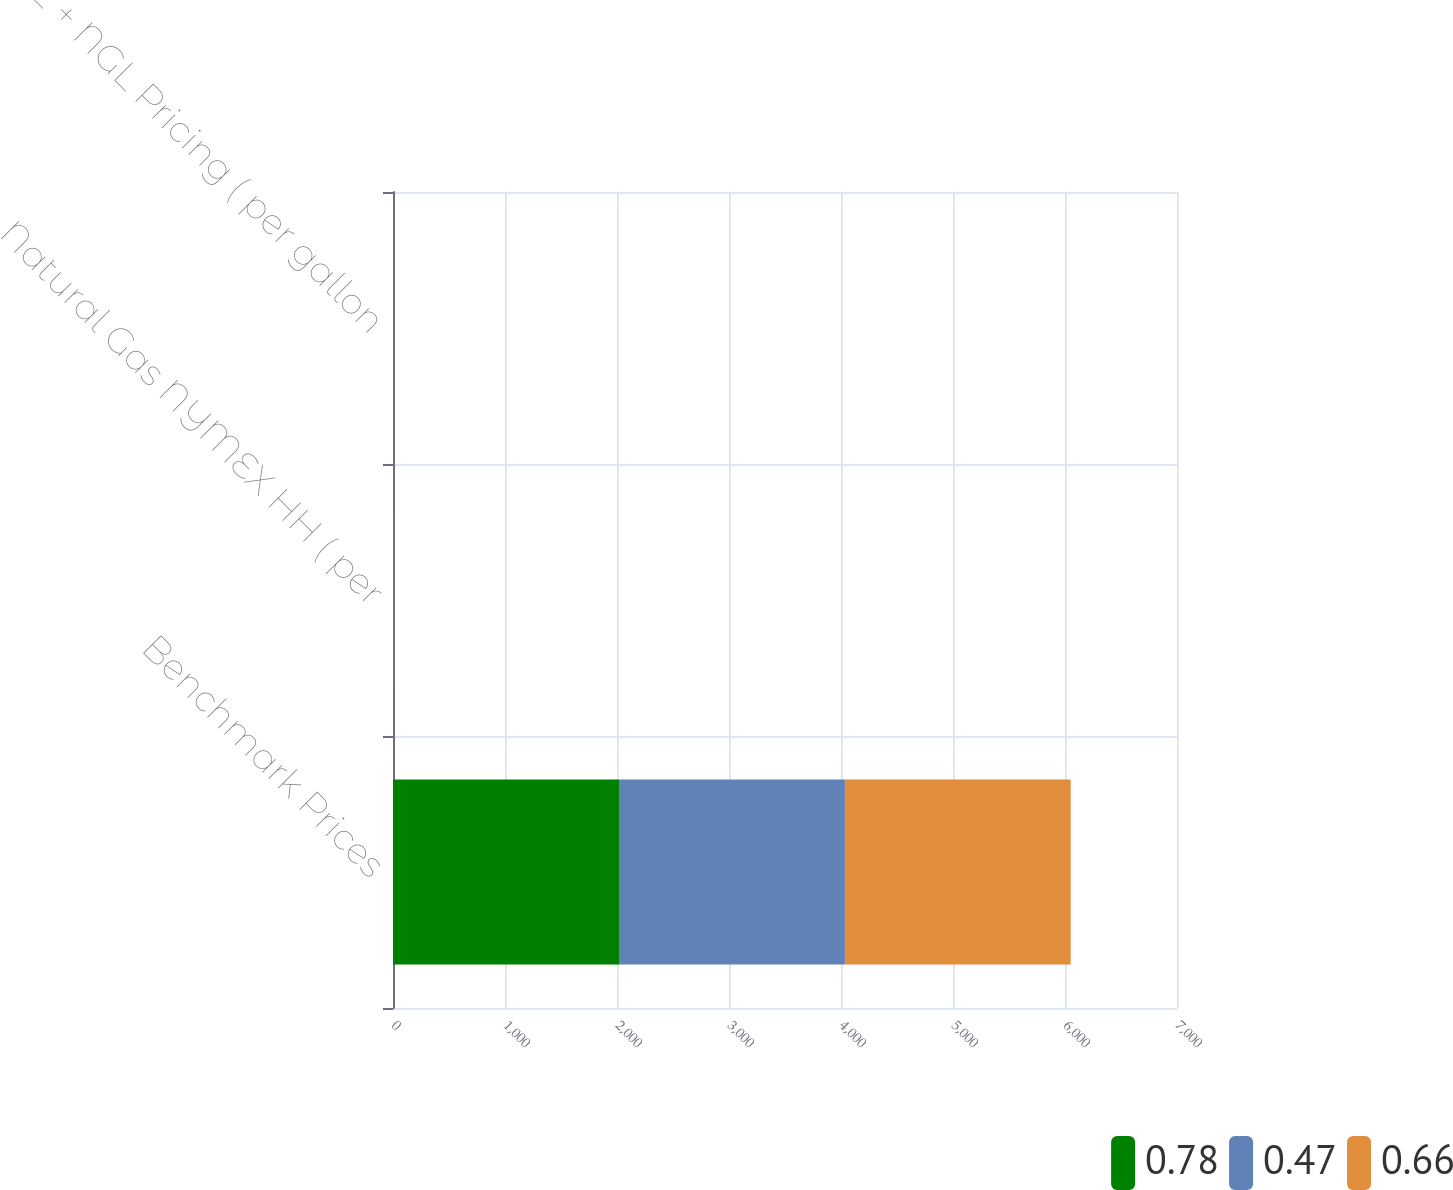Convert chart. <chart><loc_0><loc_0><loc_500><loc_500><stacked_bar_chart><ecel><fcel>Benchmark Prices<fcel>Natural Gas NYMEX HH ( per<fcel>C2 + NGL Pricing ( per gallon<nl><fcel>0.78<fcel>2018<fcel>3.07<fcel>0.78<nl><fcel>0.47<fcel>2017<fcel>3.02<fcel>0.66<nl><fcel>0.66<fcel>2016<fcel>2.55<fcel>0.47<nl></chart> 